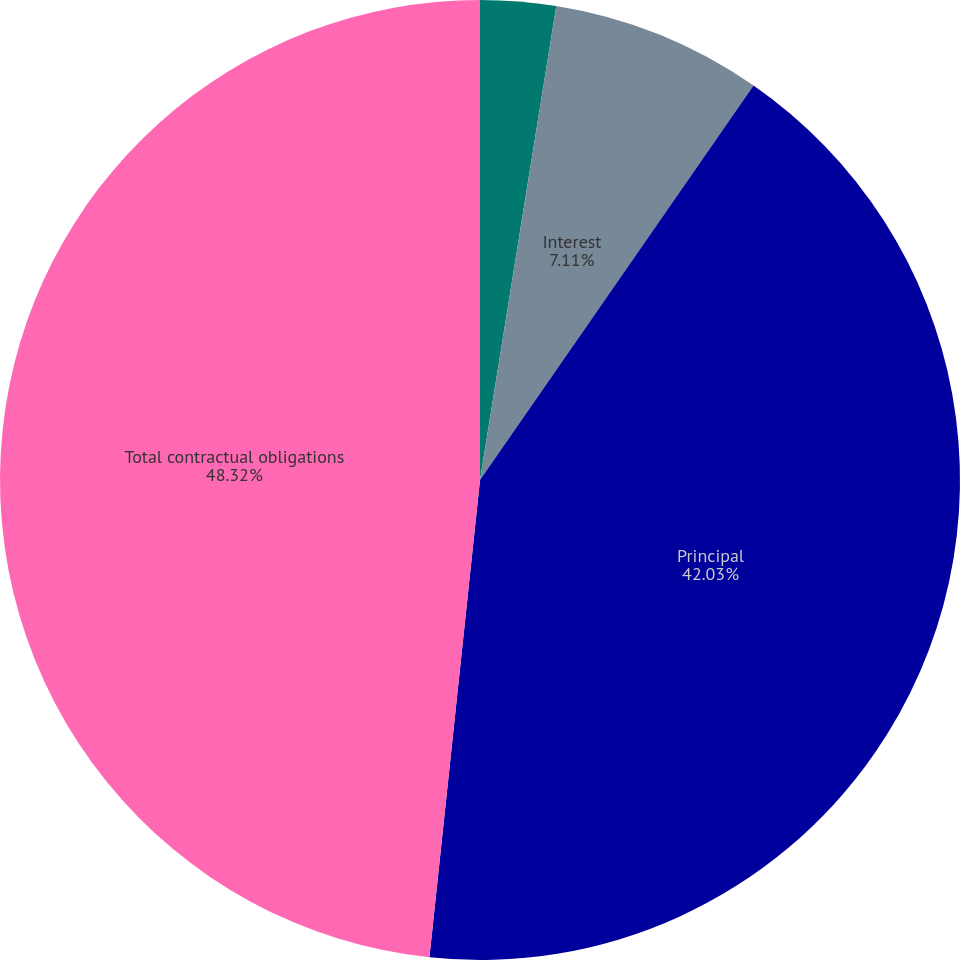Convert chart. <chart><loc_0><loc_0><loc_500><loc_500><pie_chart><fcel>Operating leases<fcel>Interest<fcel>Principal<fcel>Total contractual obligations<nl><fcel>2.54%<fcel>7.11%<fcel>42.03%<fcel>48.32%<nl></chart> 